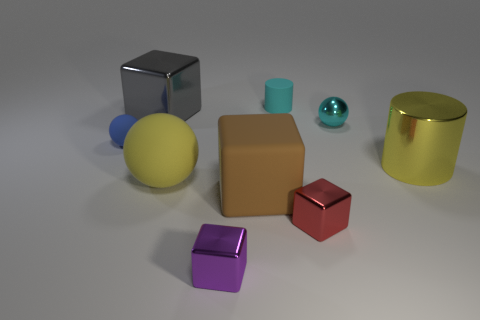Subtract all cubes. How many objects are left? 5 Subtract 0 brown balls. How many objects are left? 9 Subtract all large blue blocks. Subtract all big objects. How many objects are left? 5 Add 5 red objects. How many red objects are left? 6 Add 3 big cyan shiny objects. How many big cyan shiny objects exist? 3 